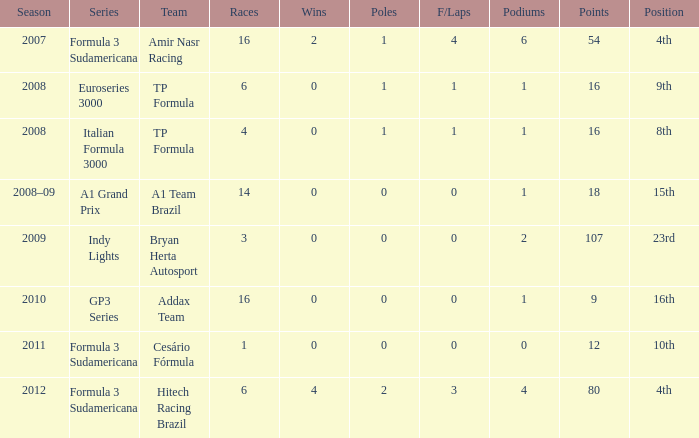Can you give me this table as a dict? {'header': ['Season', 'Series', 'Team', 'Races', 'Wins', 'Poles', 'F/Laps', 'Podiums', 'Points', 'Position'], 'rows': [['2007', 'Formula 3 Sudamericana', 'Amir Nasr Racing', '16', '2', '1', '4', '6', '54', '4th'], ['2008', 'Euroseries 3000', 'TP Formula', '6', '0', '1', '1', '1', '16', '9th'], ['2008', 'Italian Formula 3000', 'TP Formula', '4', '0', '1', '1', '1', '16', '8th'], ['2008–09', 'A1 Grand Prix', 'A1 Team Brazil', '14', '0', '0', '0', '1', '18', '15th'], ['2009', 'Indy Lights', 'Bryan Herta Autosport', '3', '0', '0', '0', '2', '107', '23rd'], ['2010', 'GP3 Series', 'Addax Team', '16', '0', '0', '0', '1', '9', '16th'], ['2011', 'Formula 3 Sudamericana', 'Cesário Fórmula', '1', '0', '0', '0', '0', '12', '10th'], ['2012', 'Formula 3 Sudamericana', 'Hitech Racing Brazil', '6', '4', '2', '3', '4', '80', '4th']]} For which team did he compete in the gp3 series? Addax Team. 